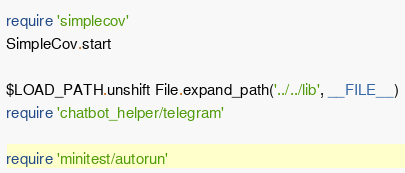Convert code to text. <code><loc_0><loc_0><loc_500><loc_500><_Ruby_>require 'simplecov'
SimpleCov.start

$LOAD_PATH.unshift File.expand_path('../../lib', __FILE__)
require 'chatbot_helper/telegram'

require 'minitest/autorun'
</code> 